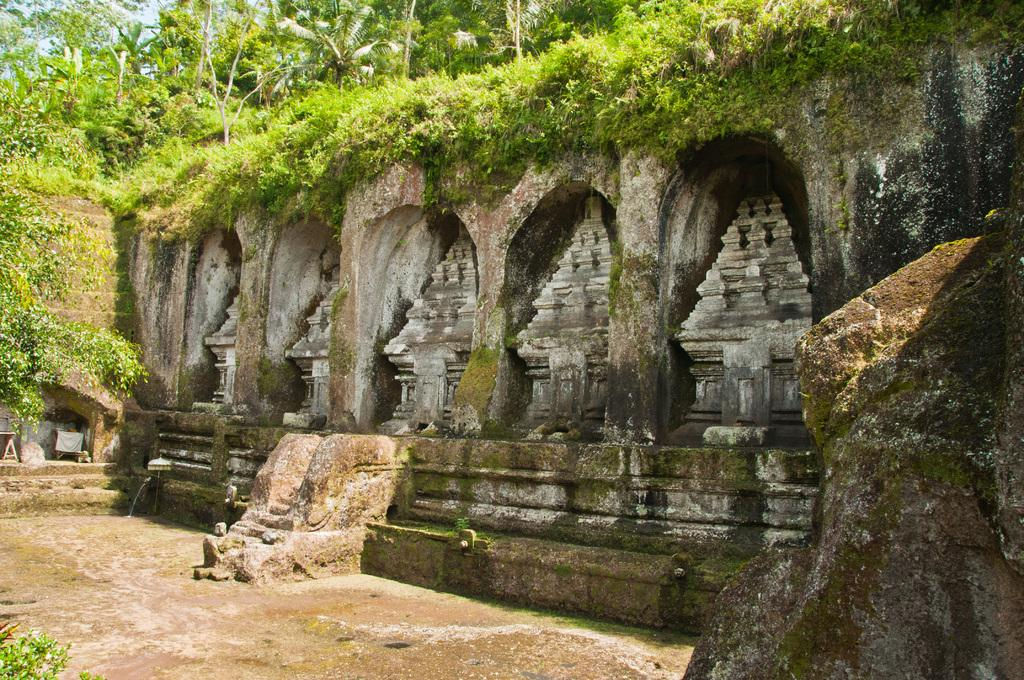What is the main structure in the image? There is a monument in the image. What type of vegetation can be seen in the image? There is a group of plants and trees in the image. What other object is present in the image? There is a rock in the image. What is visible in the background of the image? The sky is visible in the image. What type of button is attached to the coat in the image? There is no button or coat present in the image. Can you describe the ball being played with in the image? There is no ball present in the image. 